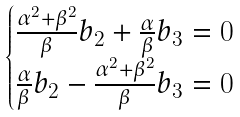<formula> <loc_0><loc_0><loc_500><loc_500>\begin{cases} \frac { \alpha ^ { 2 } + \beta ^ { 2 } } { \beta } b _ { 2 } + \frac { \alpha } { \beta } b _ { 3 } = 0 \\ \frac { \alpha } { \beta } b _ { 2 } - \frac { \alpha ^ { 2 } + \beta ^ { 2 } } { \beta } b _ { 3 } = 0 \end{cases}</formula> 